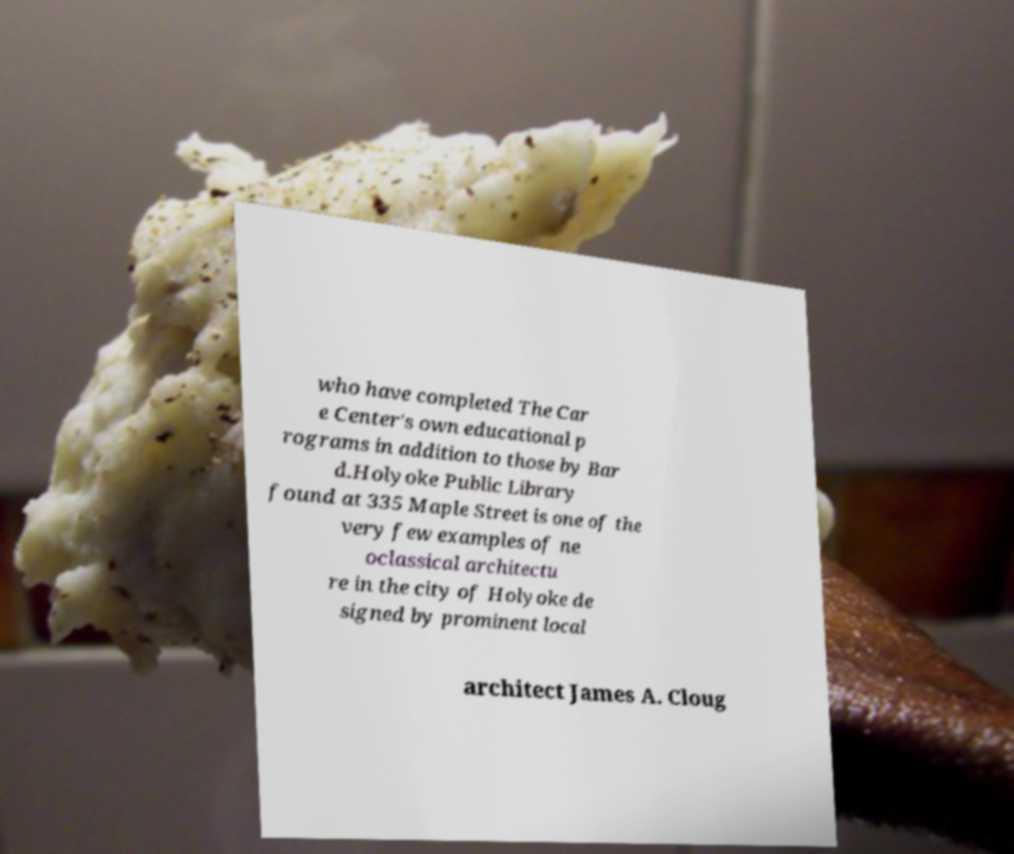What messages or text are displayed in this image? I need them in a readable, typed format. who have completed The Car e Center's own educational p rograms in addition to those by Bar d.Holyoke Public Library found at 335 Maple Street is one of the very few examples of ne oclassical architectu re in the city of Holyoke de signed by prominent local architect James A. Cloug 